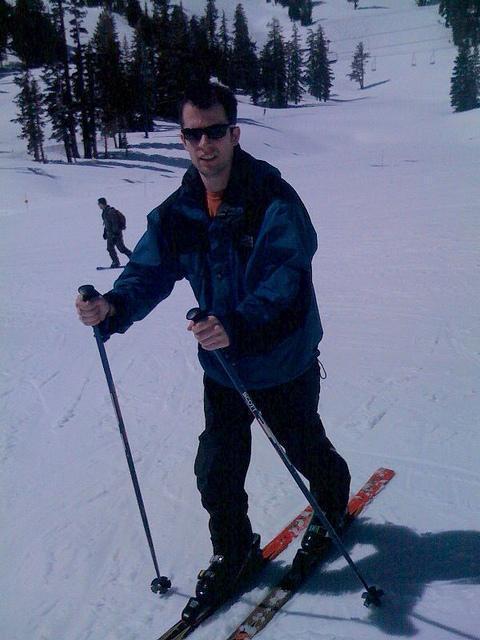How many poles are touching the snow?
Give a very brief answer. 2. How many people are in this picture?
Give a very brief answer. 2. 